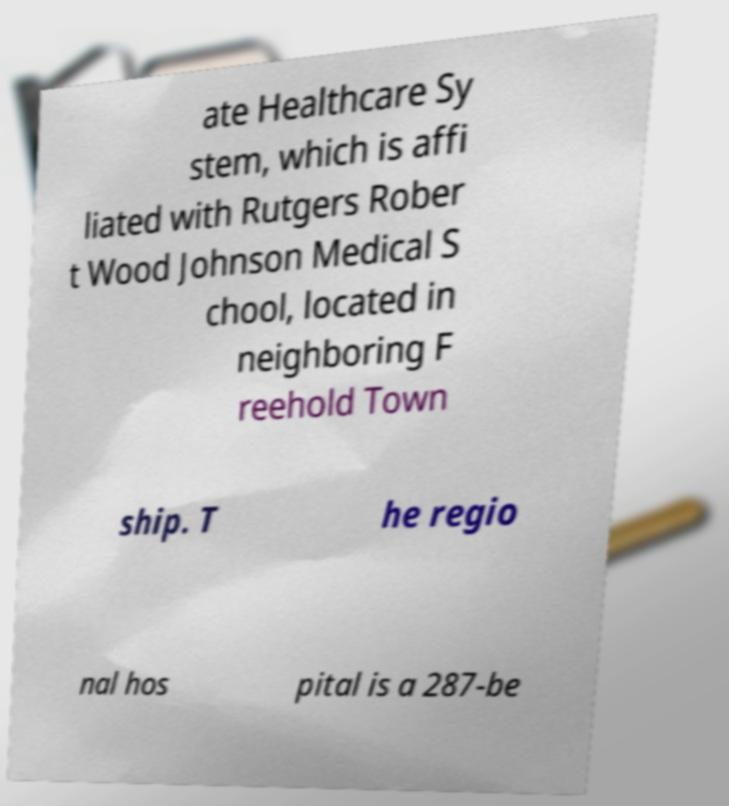Could you extract and type out the text from this image? ate Healthcare Sy stem, which is affi liated with Rutgers Rober t Wood Johnson Medical S chool, located in neighboring F reehold Town ship. T he regio nal hos pital is a 287-be 